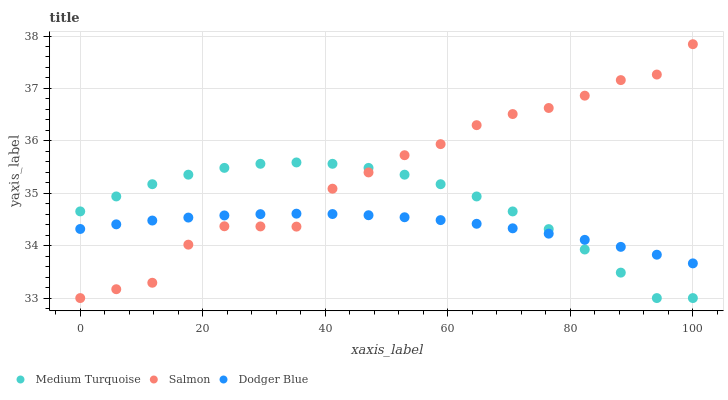Does Dodger Blue have the minimum area under the curve?
Answer yes or no. Yes. Does Salmon have the maximum area under the curve?
Answer yes or no. Yes. Does Medium Turquoise have the minimum area under the curve?
Answer yes or no. No. Does Medium Turquoise have the maximum area under the curve?
Answer yes or no. No. Is Dodger Blue the smoothest?
Answer yes or no. Yes. Is Salmon the roughest?
Answer yes or no. Yes. Is Medium Turquoise the smoothest?
Answer yes or no. No. Is Medium Turquoise the roughest?
Answer yes or no. No. Does Salmon have the lowest value?
Answer yes or no. Yes. Does Salmon have the highest value?
Answer yes or no. Yes. Does Medium Turquoise have the highest value?
Answer yes or no. No. Does Dodger Blue intersect Medium Turquoise?
Answer yes or no. Yes. Is Dodger Blue less than Medium Turquoise?
Answer yes or no. No. Is Dodger Blue greater than Medium Turquoise?
Answer yes or no. No. 